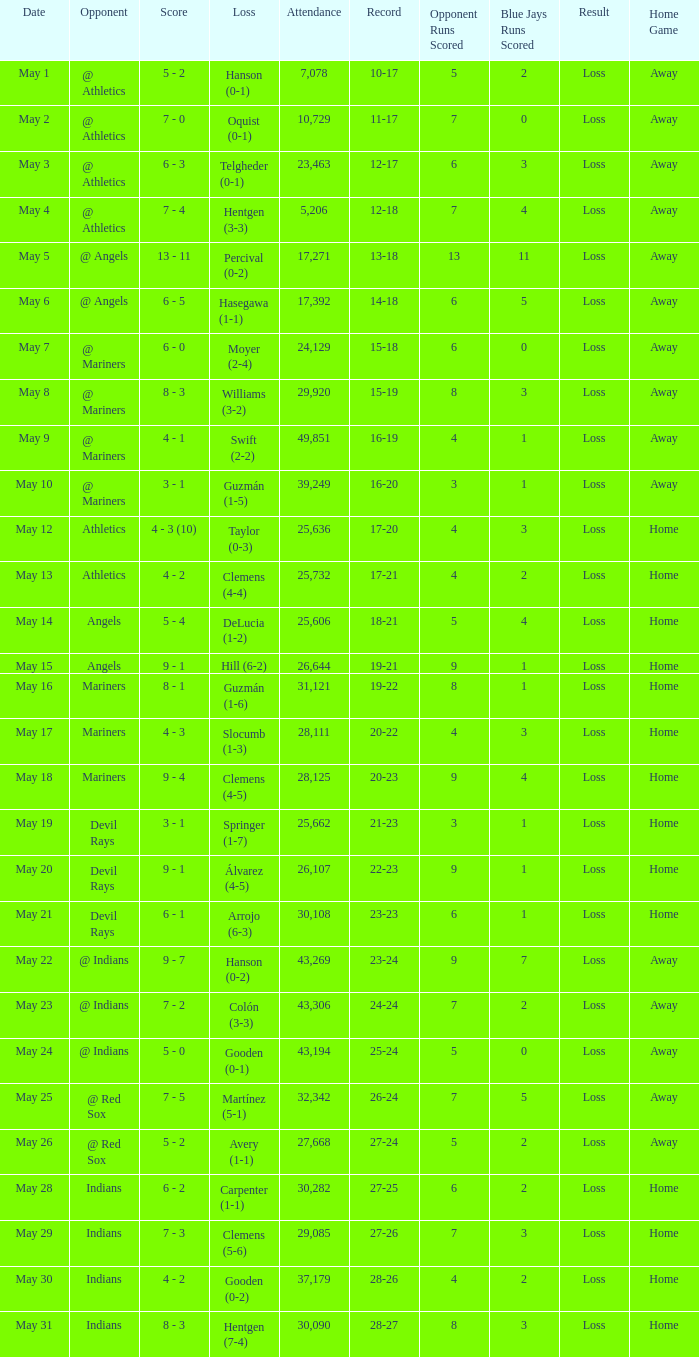When was the record 27-25? May 28. 